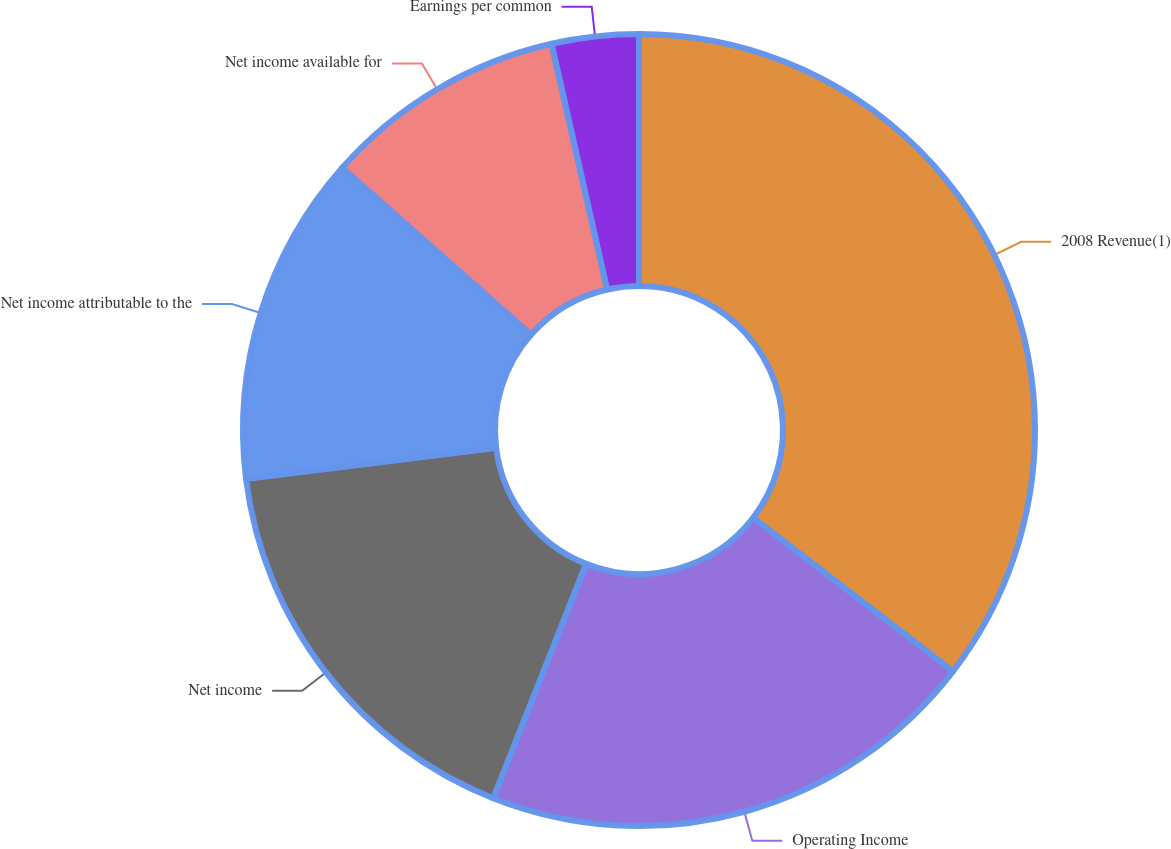Convert chart to OTSL. <chart><loc_0><loc_0><loc_500><loc_500><pie_chart><fcel>2008 Revenue(1)<fcel>Operating Income<fcel>Net income<fcel>Net income attributable to the<fcel>Net income available for<fcel>Earnings per common<nl><fcel>35.43%<fcel>20.57%<fcel>17.03%<fcel>13.49%<fcel>9.94%<fcel>3.54%<nl></chart> 